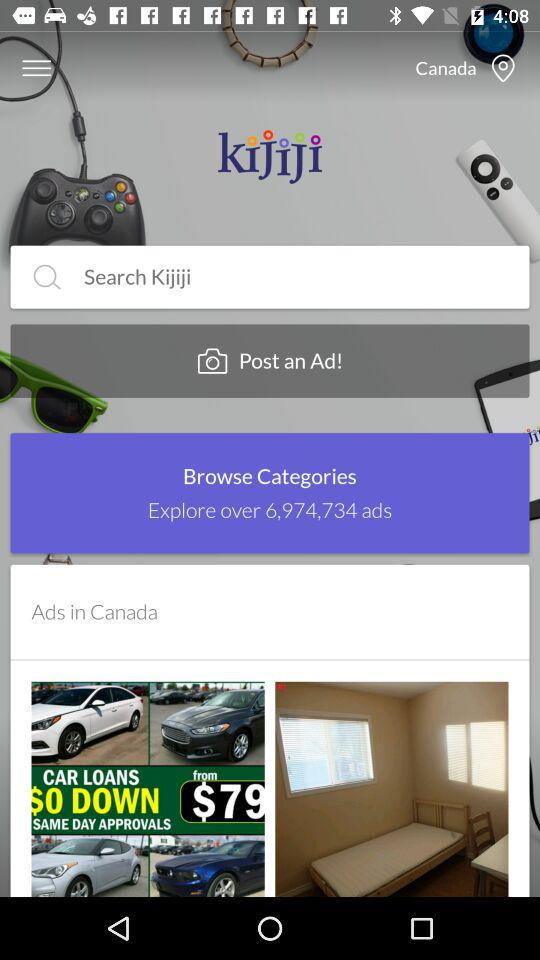What is the mentioned country? The mentioned country is Canada. 